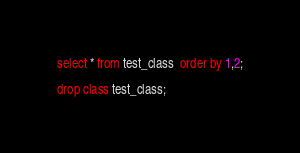<code> <loc_0><loc_0><loc_500><loc_500><_SQL_>select * from test_class  order by 1,2;

drop class test_class;

</code> 